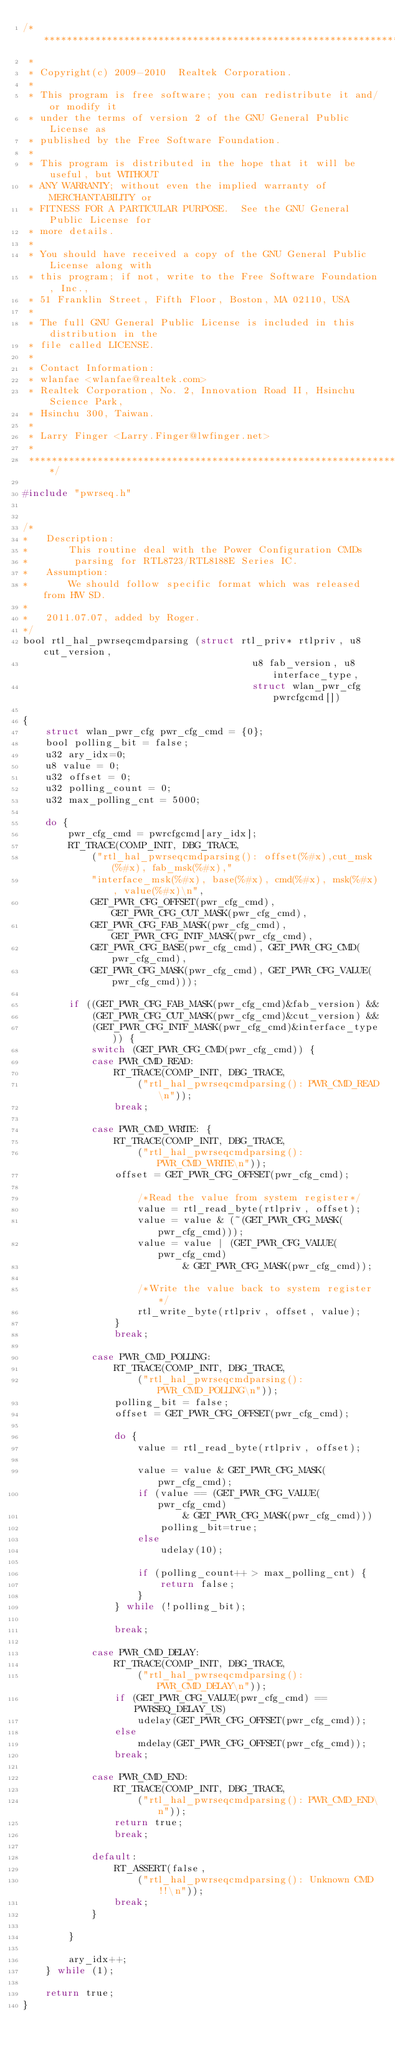Convert code to text. <code><loc_0><loc_0><loc_500><loc_500><_C_>/******************************************************************************
 *
 * Copyright(c) 2009-2010  Realtek Corporation.
 *
 * This program is free software; you can redistribute it and/or modify it
 * under the terms of version 2 of the GNU General Public License as
 * published by the Free Software Foundation.
 *
 * This program is distributed in the hope that it will be useful, but WITHOUT
 * ANY WARRANTY; without even the implied warranty of MERCHANTABILITY or
 * FITNESS FOR A PARTICULAR PURPOSE.  See the GNU General Public License for
 * more details.
 *
 * You should have received a copy of the GNU General Public License along with
 * this program; if not, write to the Free Software Foundation, Inc.,
 * 51 Franklin Street, Fifth Floor, Boston, MA 02110, USA
 *
 * The full GNU General Public License is included in this distribution in the
 * file called LICENSE.
 *
 * Contact Information:
 * wlanfae <wlanfae@realtek.com>
 * Realtek Corporation, No. 2, Innovation Road II, Hsinchu Science Park,
 * Hsinchu 300, Taiwan.
 *
 * Larry Finger <Larry.Finger@lwfinger.net>
 *
 *****************************************************************************/

#include "pwrseq.h"


/*
*	Description:
*		This routine deal with the Power Configuration CMDs
*		 parsing for RTL8723/RTL8188E Series IC.
*	Assumption:
*		We should follow specific format which was released from HW SD.
*
*	2011.07.07, added by Roger.
*/
bool rtl_hal_pwrseqcmdparsing (struct rtl_priv* rtlpriv, u8 cut_version,
										u8 fab_version, u8 interface_type,
										struct wlan_pwr_cfg	pwrcfgcmd[])

{
	struct wlan_pwr_cfg pwr_cfg_cmd = {0};
	bool polling_bit = false;
	u32 ary_idx=0;
	u8 value = 0;
	u32 offset = 0;
	u32 polling_count = 0;
	u32 max_polling_cnt = 5000;

	do {
		pwr_cfg_cmd = pwrcfgcmd[ary_idx];
		RT_TRACE(COMP_INIT, DBG_TRACE,
			("rtl_hal_pwrseqcmdparsing(): offset(%#x),cut_msk(%#x), fab_msk(%#x),"
			"interface_msk(%#x), base(%#x), cmd(%#x), msk(%#x), value(%#x)\n",
			GET_PWR_CFG_OFFSET(pwr_cfg_cmd), GET_PWR_CFG_CUT_MASK(pwr_cfg_cmd),
			GET_PWR_CFG_FAB_MASK(pwr_cfg_cmd), GET_PWR_CFG_INTF_MASK(pwr_cfg_cmd),
			GET_PWR_CFG_BASE(pwr_cfg_cmd), GET_PWR_CFG_CMD(pwr_cfg_cmd),
			GET_PWR_CFG_MASK(pwr_cfg_cmd), GET_PWR_CFG_VALUE(pwr_cfg_cmd)));

		if ((GET_PWR_CFG_FAB_MASK(pwr_cfg_cmd)&fab_version) &&
			(GET_PWR_CFG_CUT_MASK(pwr_cfg_cmd)&cut_version) &&
			(GET_PWR_CFG_INTF_MASK(pwr_cfg_cmd)&interface_type)) {
			switch (GET_PWR_CFG_CMD(pwr_cfg_cmd)) {
			case PWR_CMD_READ:
				RT_TRACE(COMP_INIT, DBG_TRACE,
					("rtl_hal_pwrseqcmdparsing(): PWR_CMD_READ\n"));
				break;

			case PWR_CMD_WRITE: {
				RT_TRACE(COMP_INIT, DBG_TRACE,
					("rtl_hal_pwrseqcmdparsing(): PWR_CMD_WRITE\n"));
				offset = GET_PWR_CFG_OFFSET(pwr_cfg_cmd);

					/*Read the value from system register*/
					value = rtl_read_byte(rtlpriv, offset);
					value = value & (~(GET_PWR_CFG_MASK(pwr_cfg_cmd)));
					value = value | (GET_PWR_CFG_VALUE(pwr_cfg_cmd)
							& GET_PWR_CFG_MASK(pwr_cfg_cmd));

					/*Write the value back to system register*/
					rtl_write_byte(rtlpriv, offset, value);
				}
				break;

			case PWR_CMD_POLLING:
				RT_TRACE(COMP_INIT, DBG_TRACE,
					("rtl_hal_pwrseqcmdparsing(): PWR_CMD_POLLING\n"));
				polling_bit = false;
				offset = GET_PWR_CFG_OFFSET(pwr_cfg_cmd);

				do {
					value = rtl_read_byte(rtlpriv, offset);

					value = value & GET_PWR_CFG_MASK(pwr_cfg_cmd);
					if (value == (GET_PWR_CFG_VALUE(pwr_cfg_cmd)
							& GET_PWR_CFG_MASK(pwr_cfg_cmd)))
						polling_bit=true;
					else
						udelay(10);

					if (polling_count++ > max_polling_cnt) {
						return false;
					}
				} while (!polling_bit);

				break;

			case PWR_CMD_DELAY:
				RT_TRACE(COMP_INIT, DBG_TRACE,
					("rtl_hal_pwrseqcmdparsing(): PWR_CMD_DELAY\n"));
				if (GET_PWR_CFG_VALUE(pwr_cfg_cmd) == PWRSEQ_DELAY_US)
					udelay(GET_PWR_CFG_OFFSET(pwr_cfg_cmd));
				else
					mdelay(GET_PWR_CFG_OFFSET(pwr_cfg_cmd));
				break;

			case PWR_CMD_END:
				RT_TRACE(COMP_INIT, DBG_TRACE,
					("rtl_hal_pwrseqcmdparsing(): PWR_CMD_END\n"));
				return true;
				break;

			default:
				RT_ASSERT(false,
					("rtl_hal_pwrseqcmdparsing(): Unknown CMD!!\n"));
				break;
			}

		}

		ary_idx++;
	} while (1);

	return true;
}
</code> 